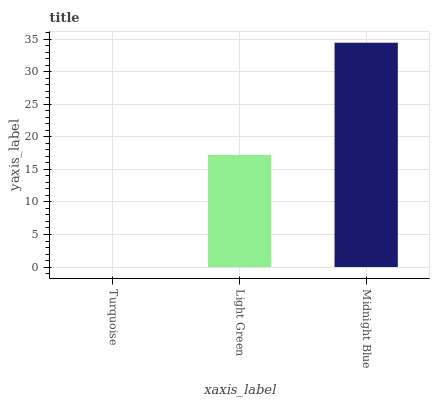Is Turquoise the minimum?
Answer yes or no. Yes. Is Midnight Blue the maximum?
Answer yes or no. Yes. Is Light Green the minimum?
Answer yes or no. No. Is Light Green the maximum?
Answer yes or no. No. Is Light Green greater than Turquoise?
Answer yes or no. Yes. Is Turquoise less than Light Green?
Answer yes or no. Yes. Is Turquoise greater than Light Green?
Answer yes or no. No. Is Light Green less than Turquoise?
Answer yes or no. No. Is Light Green the high median?
Answer yes or no. Yes. Is Light Green the low median?
Answer yes or no. Yes. Is Turquoise the high median?
Answer yes or no. No. Is Midnight Blue the low median?
Answer yes or no. No. 